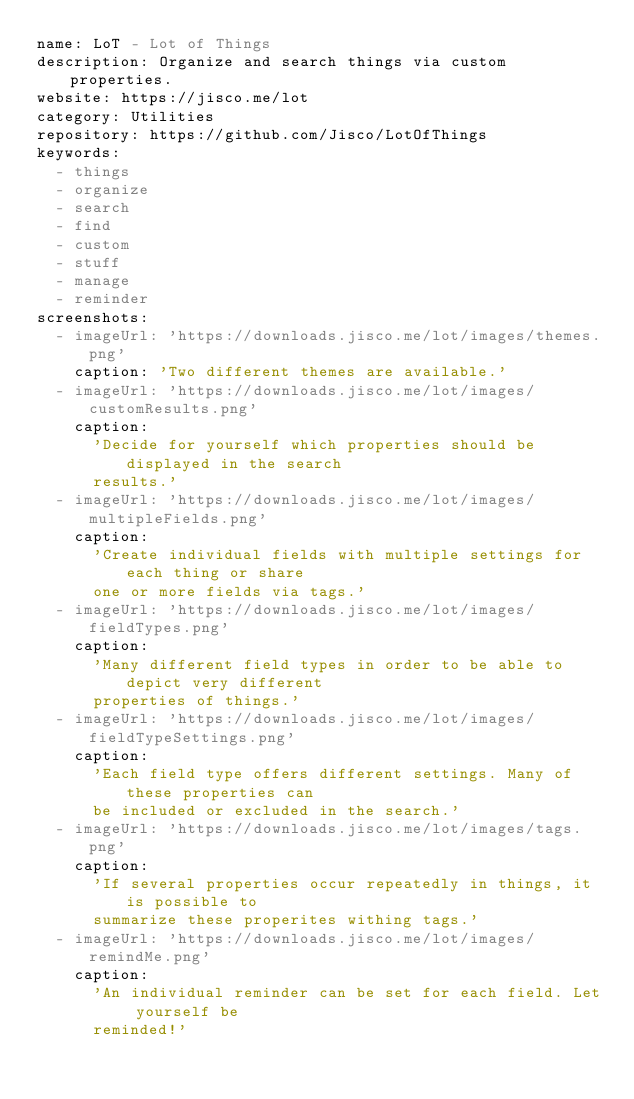<code> <loc_0><loc_0><loc_500><loc_500><_YAML_>name: LoT - Lot of Things
description: Organize and search things via custom properties.
website: https://jisco.me/lot
category: Utilities
repository: https://github.com/Jisco/LotOfThings
keywords:
  - things
  - organize
  - search
  - find
  - custom
  - stuff
  - manage
  - reminder
screenshots:
  - imageUrl: 'https://downloads.jisco.me/lot/images/themes.png'
    caption: 'Two different themes are available.'
  - imageUrl: 'https://downloads.jisco.me/lot/images/customResults.png'
    caption:
      'Decide for yourself which properties should be displayed in the search
      results.'
  - imageUrl: 'https://downloads.jisco.me/lot/images/multipleFields.png'
    caption:
      'Create individual fields with multiple settings for each thing or share
      one or more fields via tags.'
  - imageUrl: 'https://downloads.jisco.me/lot/images/fieldTypes.png'
    caption:
      'Many different field types in order to be able to depict very different
      properties of things.'
  - imageUrl: 'https://downloads.jisco.me/lot/images/fieldTypeSettings.png'
    caption:
      'Each field type offers different settings. Many of these properties can
      be included or excluded in the search.'
  - imageUrl: 'https://downloads.jisco.me/lot/images/tags.png'
    caption:
      'If several properties occur repeatedly in things, it is possible to
      summarize these properites withing tags.'
  - imageUrl: 'https://downloads.jisco.me/lot/images/remindMe.png'
    caption:
      'An individual reminder can be set for each field. Let yourself be
      reminded!'
</code> 